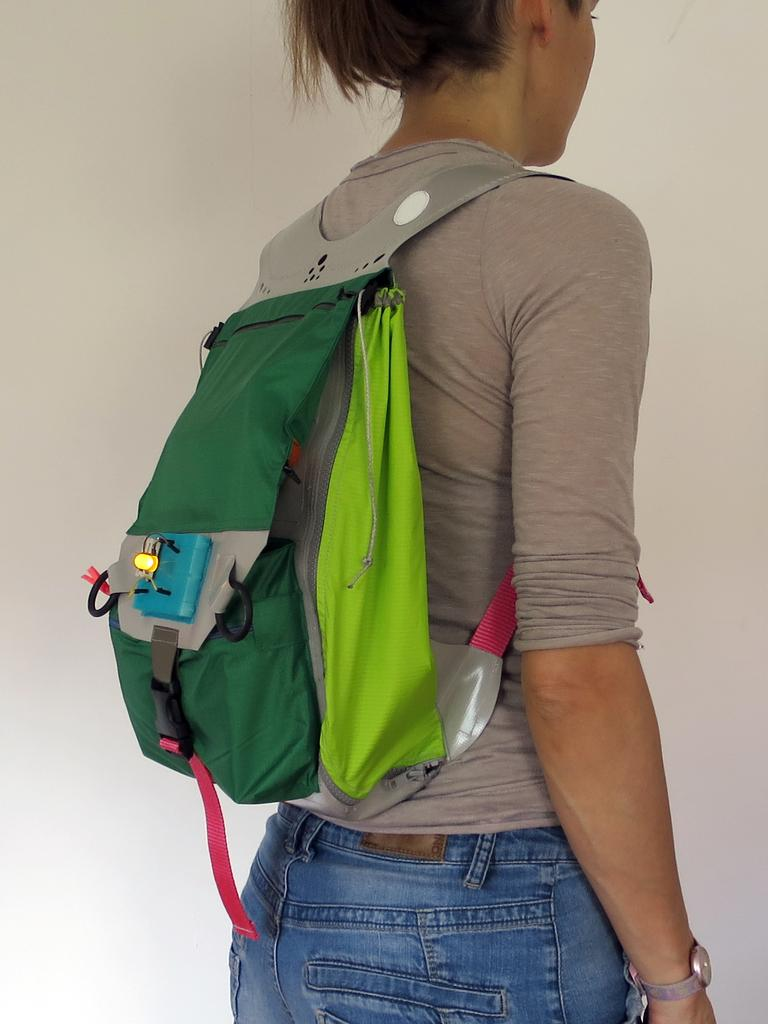Who is the main subject in the image? There is a lady in the image. What is the lady wearing on her back? The lady is wearing a backpack. Can you describe the colors of the backpack? The backpack is in green, red, and ash colors. What type of glass is the lady holding in the image? There is no glass present in the image; the lady is wearing a backpack. Is the lady in a recess in the image? The provided facts do not mention a recess, so it cannot be determined from the image. 